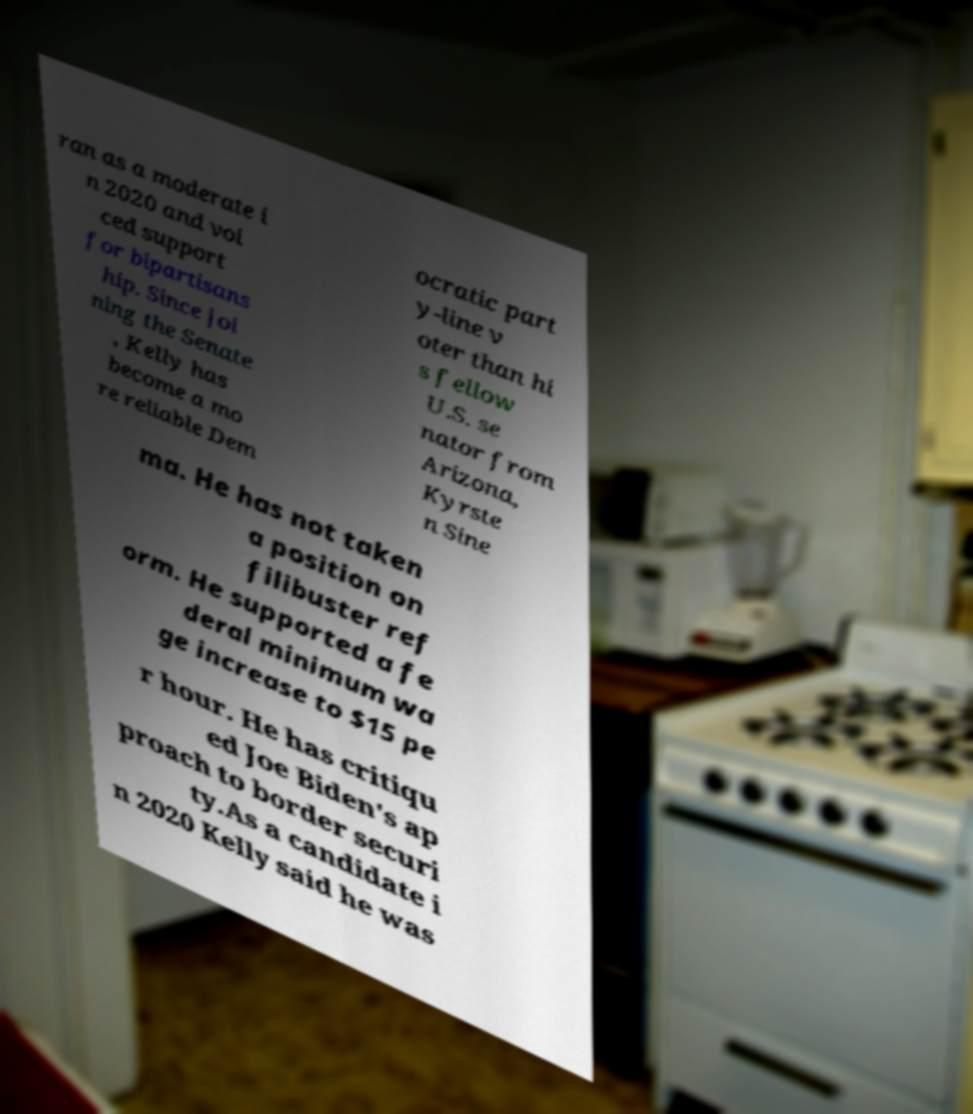Could you extract and type out the text from this image? ran as a moderate i n 2020 and voi ced support for bipartisans hip. Since joi ning the Senate , Kelly has become a mo re reliable Dem ocratic part y-line v oter than hi s fellow U.S. se nator from Arizona, Kyrste n Sine ma. He has not taken a position on filibuster ref orm. He supported a fe deral minimum wa ge increase to $15 pe r hour. He has critiqu ed Joe Biden's ap proach to border securi ty.As a candidate i n 2020 Kelly said he was 